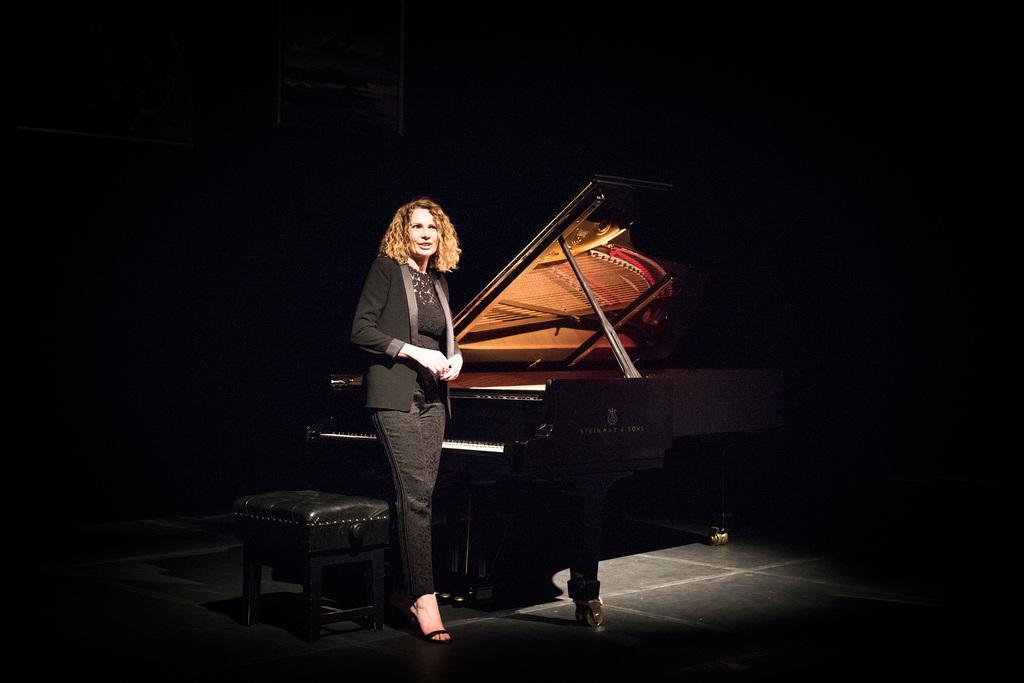Please provide a concise description of this image. In this image i can see a woman standing at right there is a piano. 